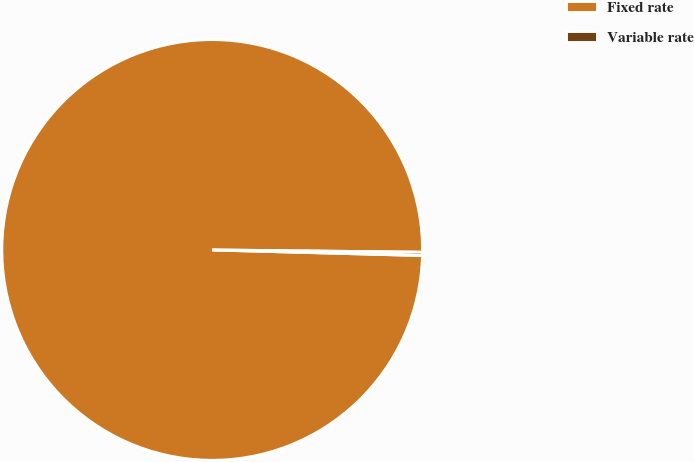Convert chart to OTSL. <chart><loc_0><loc_0><loc_500><loc_500><pie_chart><fcel>Fixed rate<fcel>Variable rate<nl><fcel>99.75%<fcel>0.25%<nl></chart> 